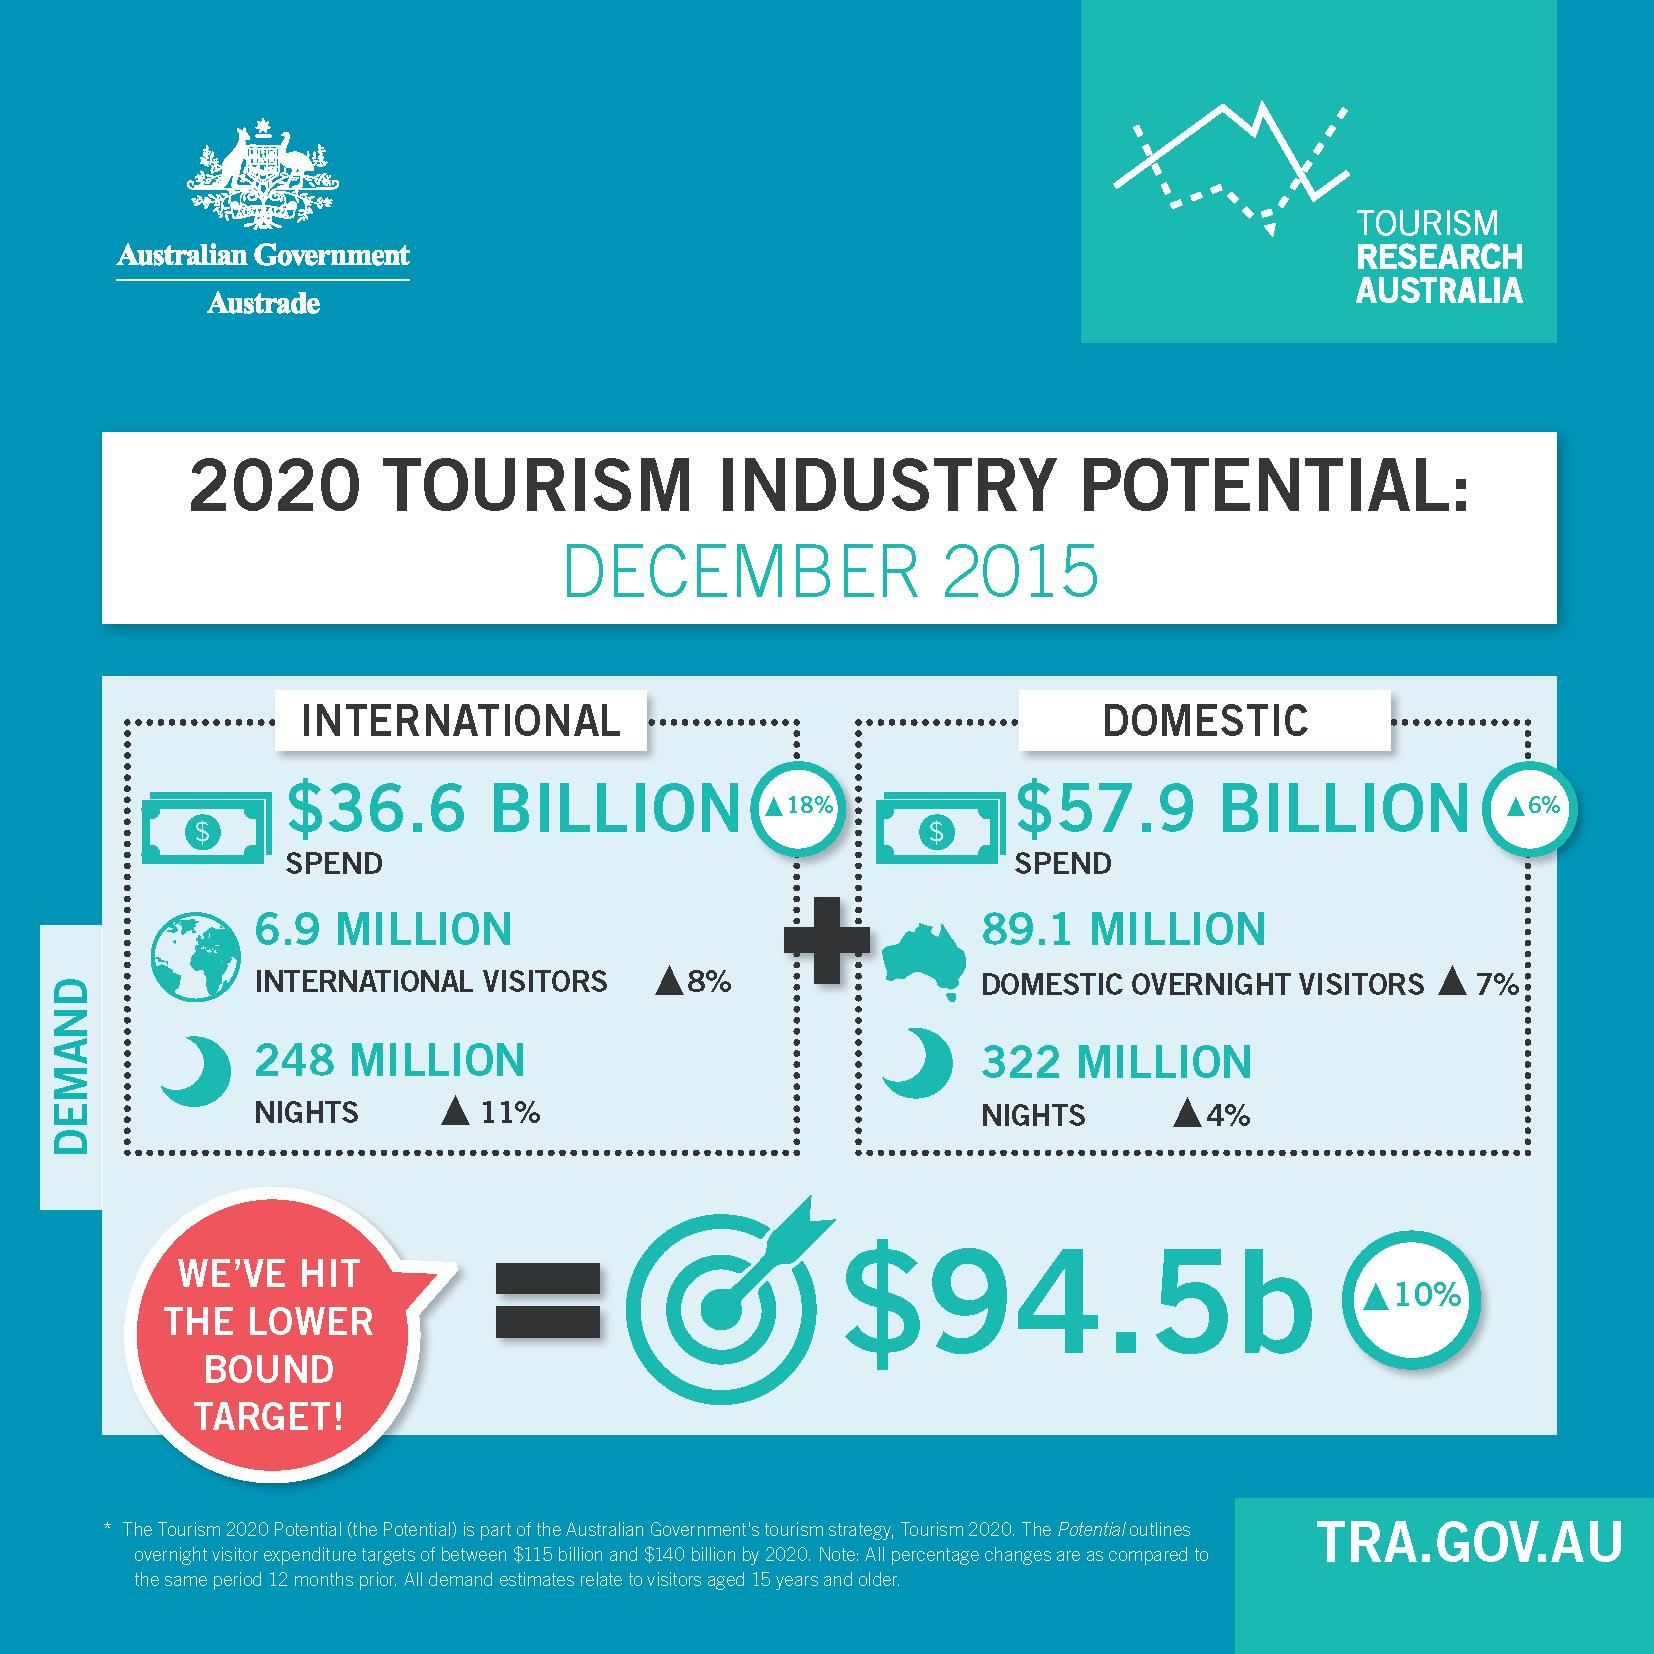Draw attention to some important aspects in this diagram. The report was published in 2015. The domestic tourism expenditure for the given year is $57.9 billion. The domestic sector has a higher spend than the international sector. The number of domestic hotel nights booked is significantly higher than the number of international hotel nights booked. In the year 2020, the number of domestic overnight visitors was estimated to be 89.1 million. 